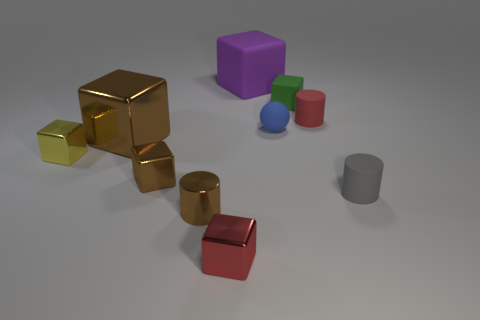How many objects are there in total? There are a total of nine objects in the image, including a variety of blocks and cylinders in different colors. Can you describe the arrangement of these objects? The objects are scattered with no apparent pattern. The golden blocks are clustered towards the left, suggesting they might be related or part of a set, while the other objects are more loosely arranged. 